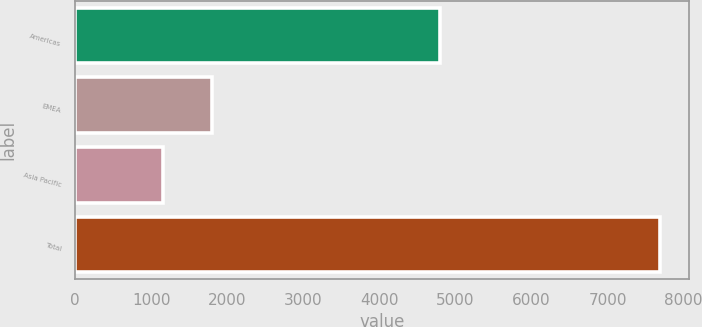Convert chart. <chart><loc_0><loc_0><loc_500><loc_500><bar_chart><fcel>Americas<fcel>EMEA<fcel>Asia Pacific<fcel>Total<nl><fcel>4802.2<fcel>1804.56<fcel>1151.3<fcel>7683.9<nl></chart> 